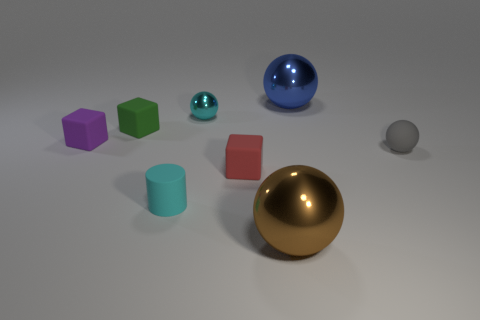How many shiny objects are either red things or gray objects?
Offer a terse response. 0. There is a brown thing that is to the right of the small thing behind the tiny green thing; how many small green matte things are on the left side of it?
Offer a very short reply. 1. Is the size of the sphere that is in front of the rubber sphere the same as the cyan thing in front of the tiny purple cube?
Ensure brevity in your answer.  No. There is a brown object that is the same shape as the small cyan metallic thing; what material is it?
Your answer should be compact. Metal. What number of big objects are rubber spheres or spheres?
Provide a succinct answer. 2. What material is the purple block?
Your answer should be very brief. Rubber. There is a sphere that is both in front of the blue sphere and behind the green rubber object; what is its material?
Make the answer very short. Metal. Do the small cylinder and the big metal object behind the small metal object have the same color?
Give a very brief answer. No. There is a blue sphere that is the same size as the brown ball; what is it made of?
Offer a terse response. Metal. Are there any other large objects that have the same material as the gray thing?
Your answer should be very brief. No. 